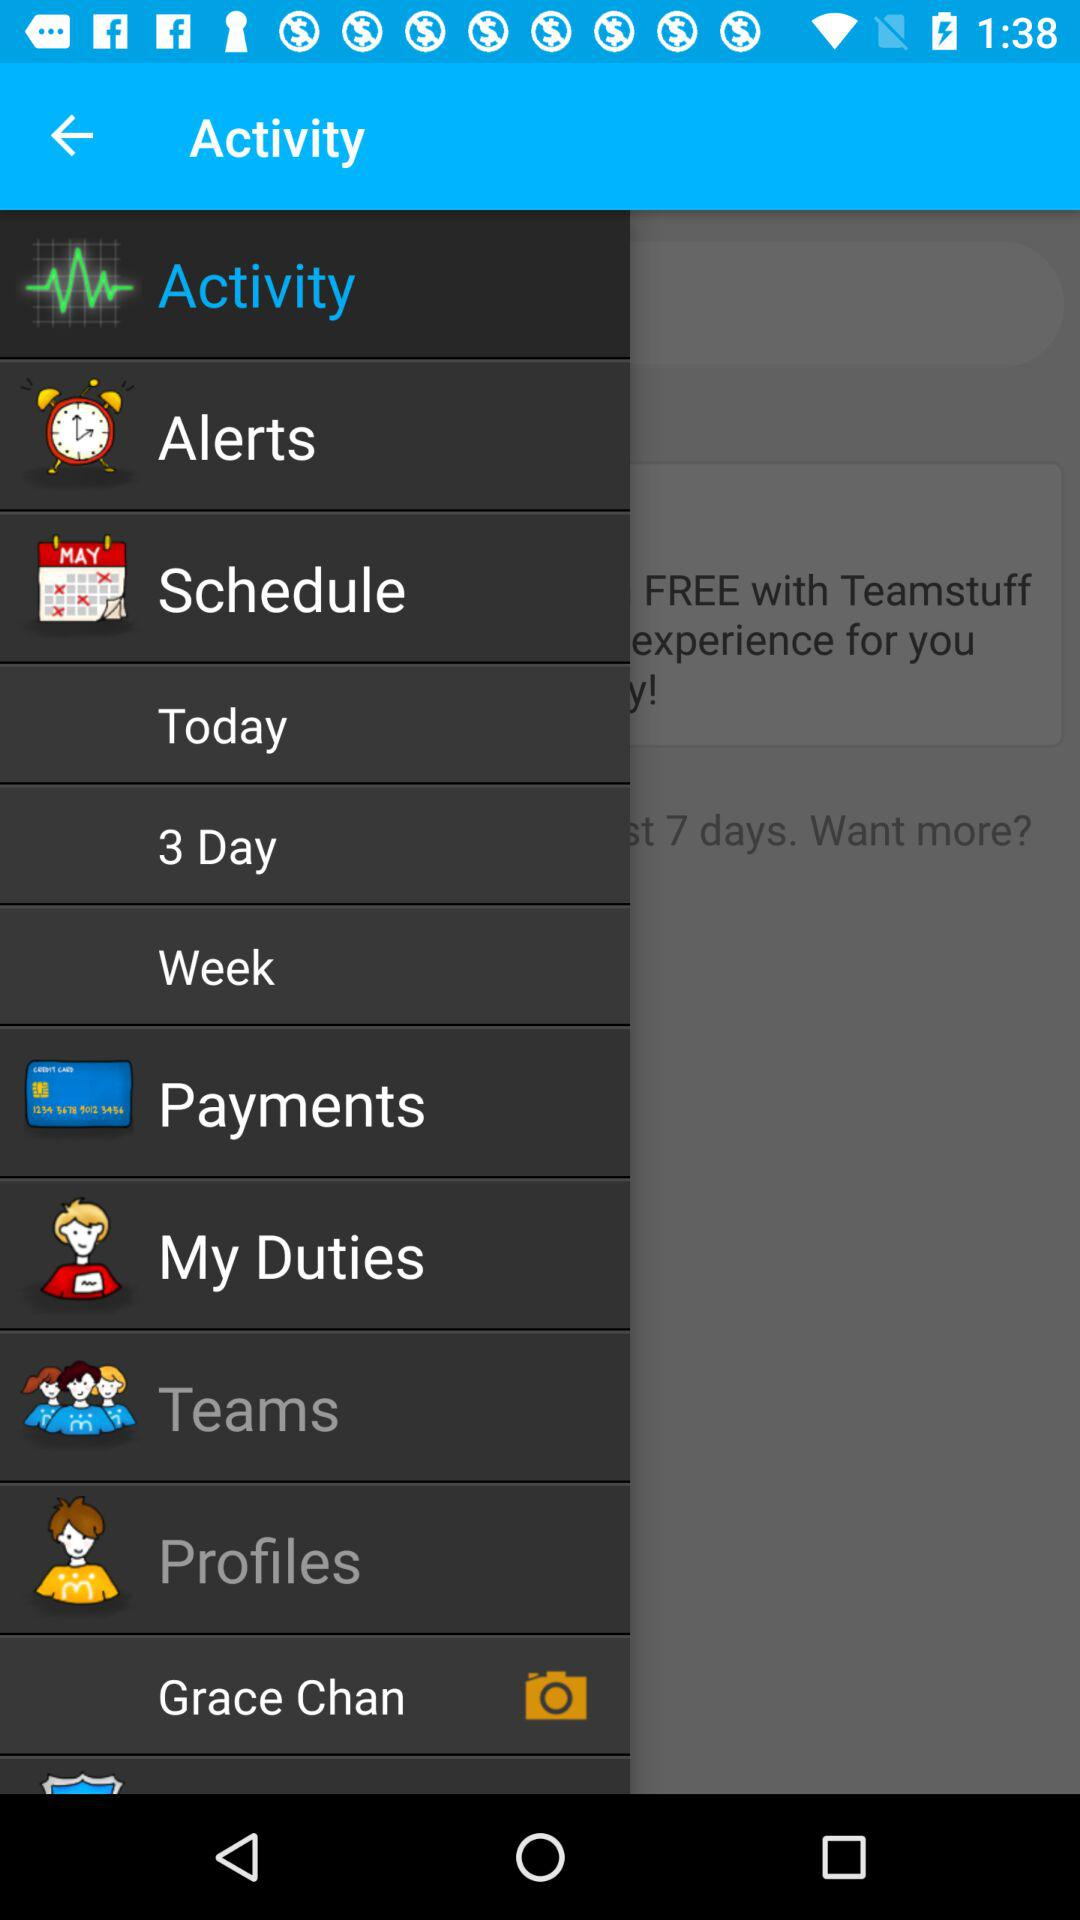What is the profile name? The profile name is Grace Chan. 